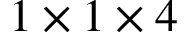Convert formula to latex. <formula><loc_0><loc_0><loc_500><loc_500>1 \times 1 \times 4</formula> 